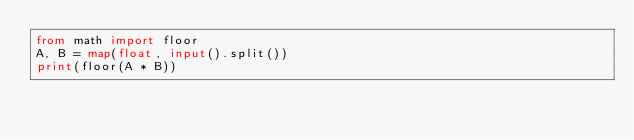<code> <loc_0><loc_0><loc_500><loc_500><_Python_>from math import floor
A, B = map(float, input().split())
print(floor(A * B))</code> 